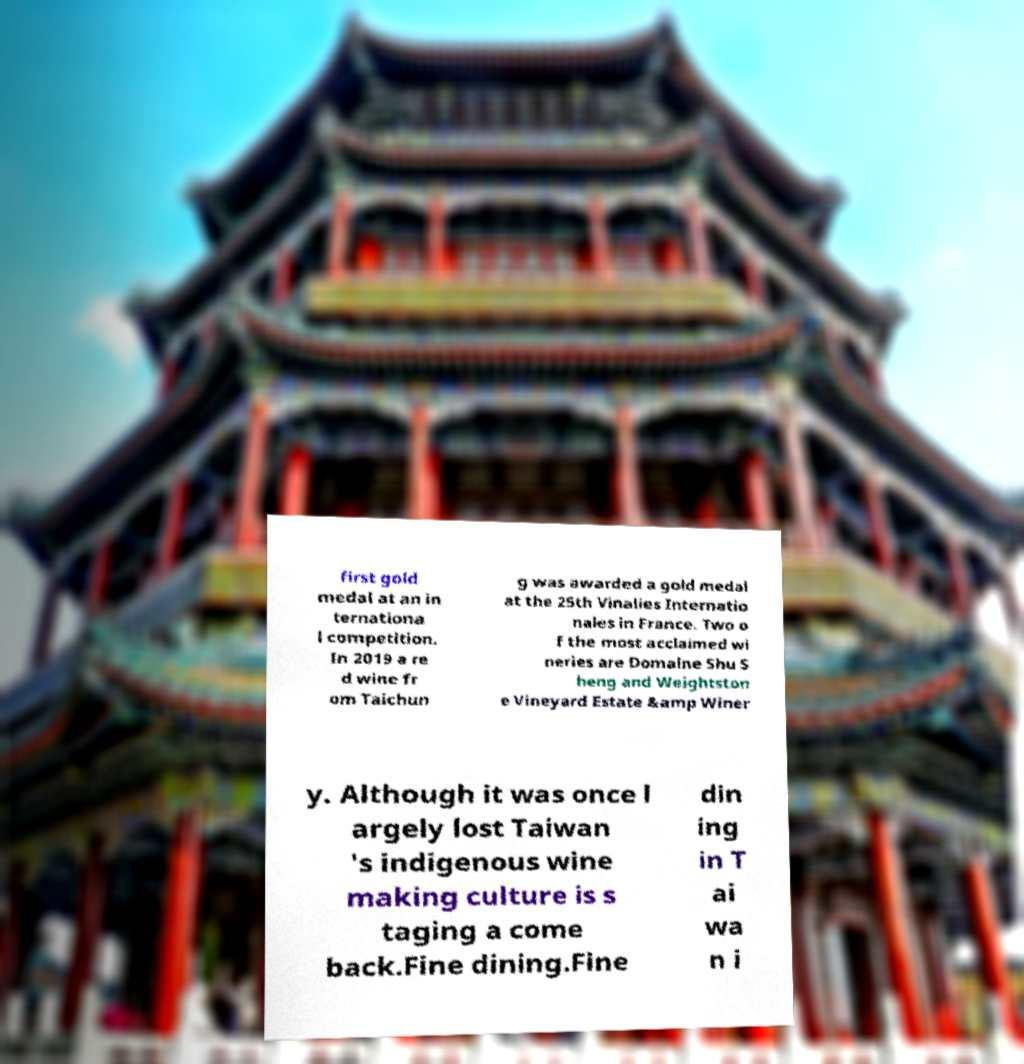Could you assist in decoding the text presented in this image and type it out clearly? first gold medal at an in ternationa l competition. In 2019 a re d wine fr om Taichun g was awarded a gold medal at the 25th Vinalies Internatio nales in France. Two o f the most acclaimed wi neries are Domaine Shu S heng and Weightston e Vineyard Estate &amp Winer y. Although it was once l argely lost Taiwan 's indigenous wine making culture is s taging a come back.Fine dining.Fine din ing in T ai wa n i 